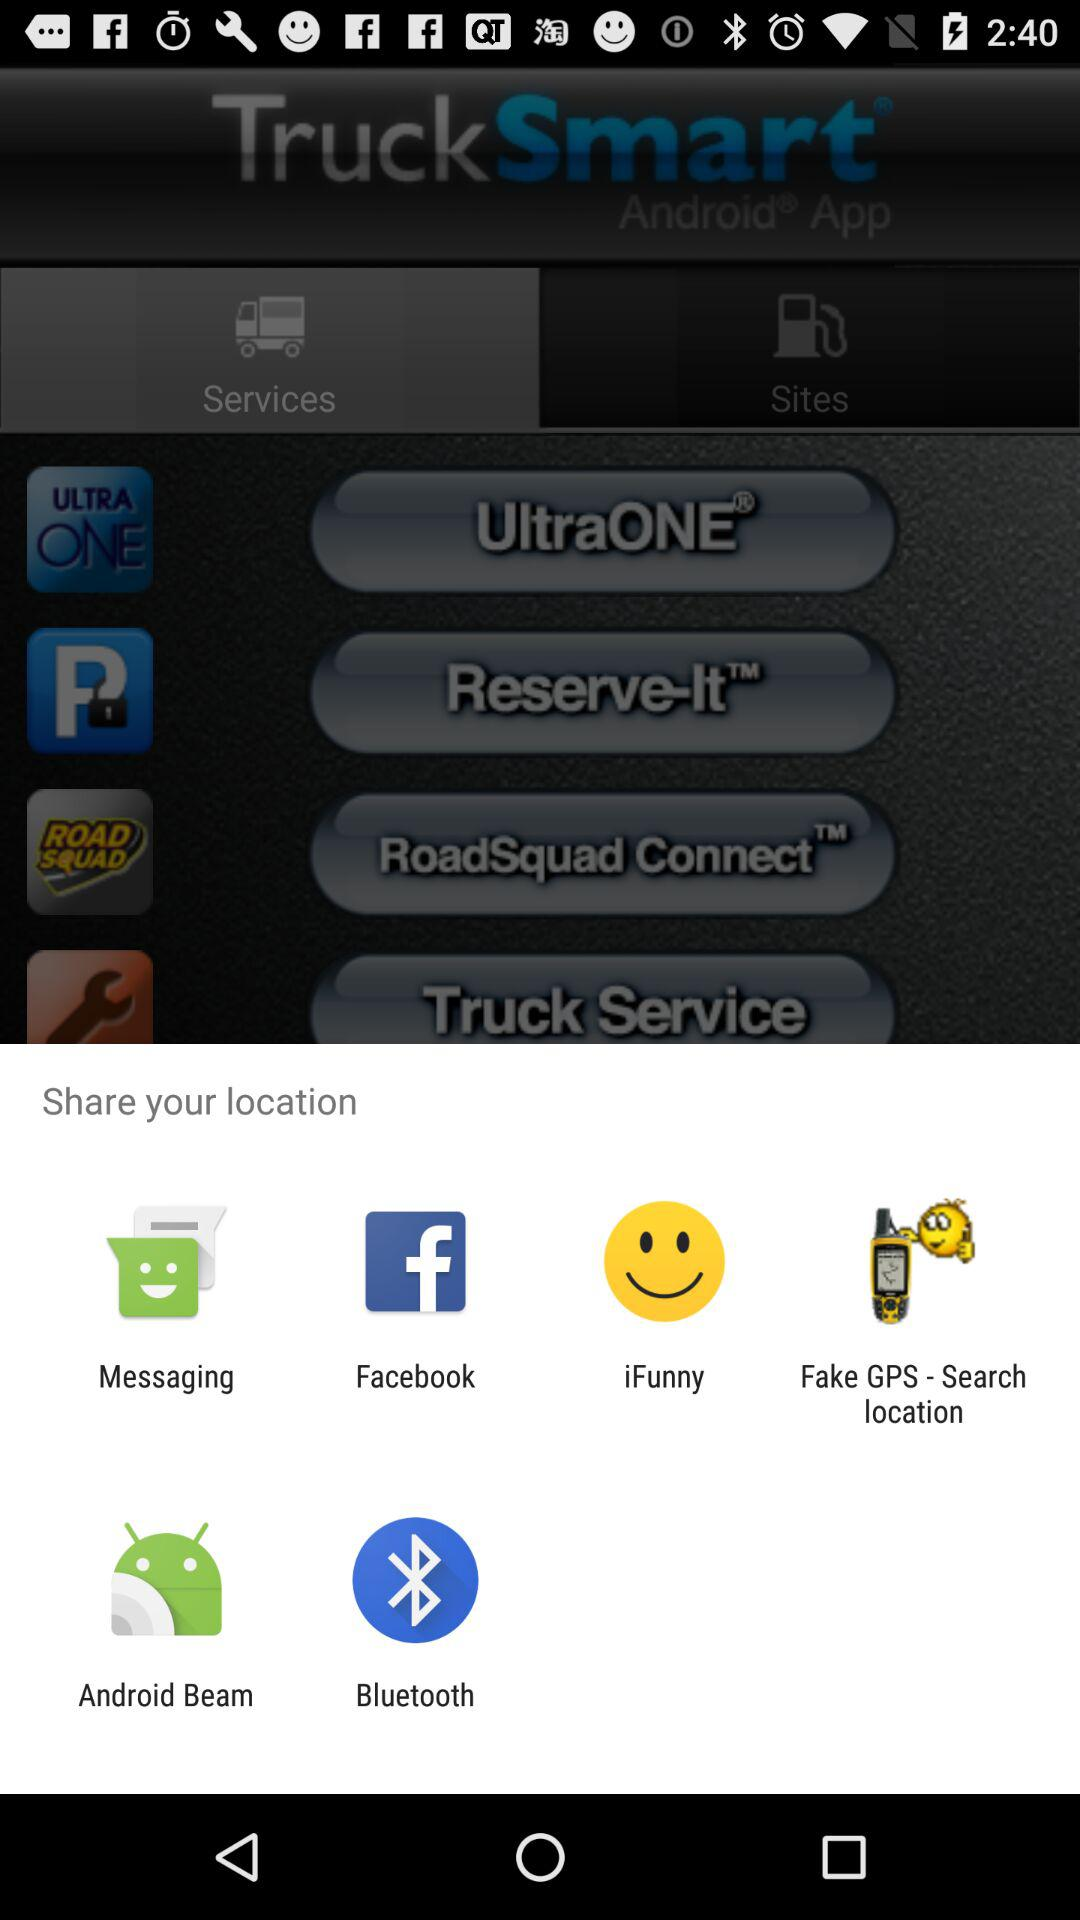Through which applications can we share the location? You can share the location through "Messaging", "Facebook", "iFunny", "Fake GPS - Search location", "Android Beam" and "Bluetooth". 